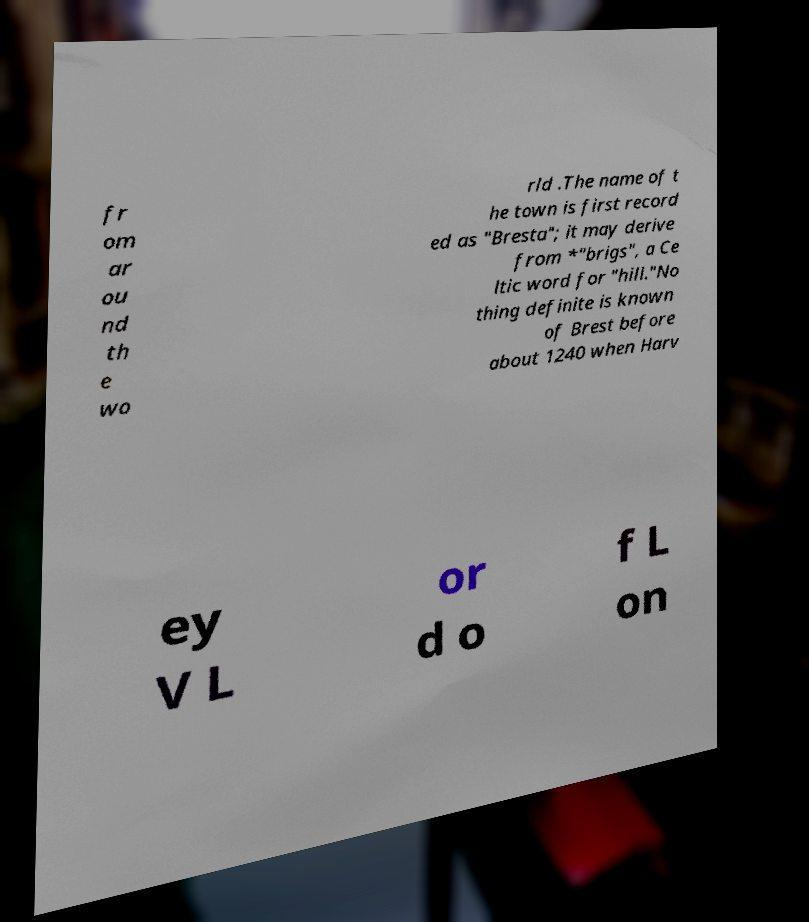What messages or text are displayed in this image? I need them in a readable, typed format. fr om ar ou nd th e wo rld .The name of t he town is first record ed as "Bresta"; it may derive from *"brigs", a Ce ltic word for "hill."No thing definite is known of Brest before about 1240 when Harv ey V L or d o f L on 